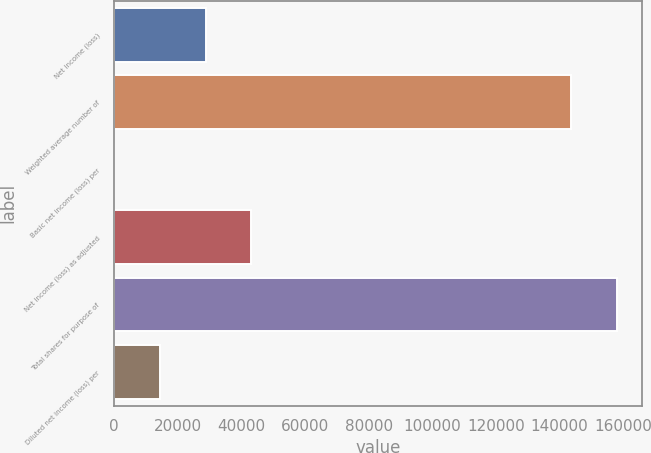<chart> <loc_0><loc_0><loc_500><loc_500><bar_chart><fcel>Net income (loss)<fcel>Weighted average number of<fcel>Basic net income (loss) per<fcel>Net income (loss) as adjusted<fcel>Total shares for purpose of<fcel>Diluted net income (loss) per<nl><fcel>28721<fcel>143604<fcel>0.2<fcel>43081.3<fcel>157964<fcel>14360.6<nl></chart> 